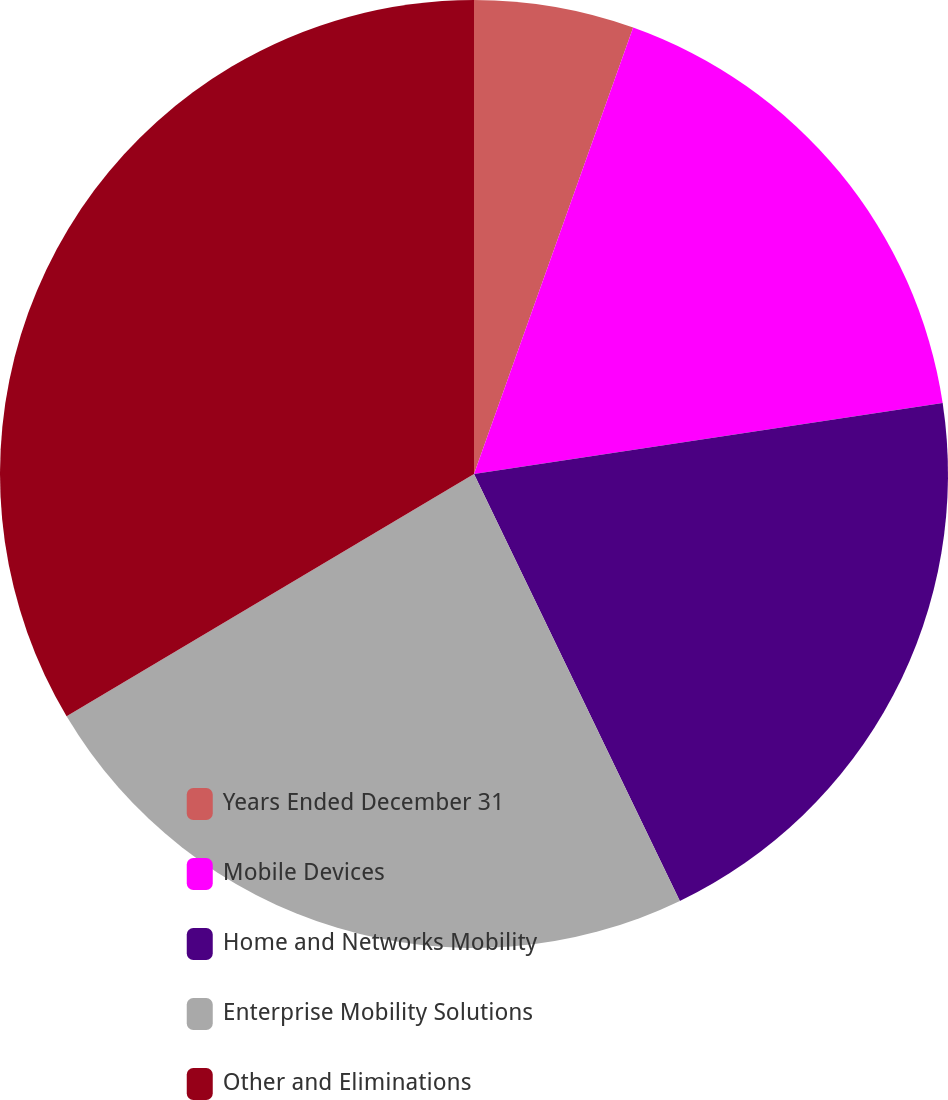Convert chart to OTSL. <chart><loc_0><loc_0><loc_500><loc_500><pie_chart><fcel>Years Ended December 31<fcel>Mobile Devices<fcel>Home and Networks Mobility<fcel>Enterprise Mobility Solutions<fcel>Other and Eliminations<nl><fcel>5.45%<fcel>17.16%<fcel>20.24%<fcel>23.61%<fcel>33.54%<nl></chart> 